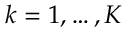Convert formula to latex. <formula><loc_0><loc_0><loc_500><loc_500>k = 1 , \dots , K</formula> 